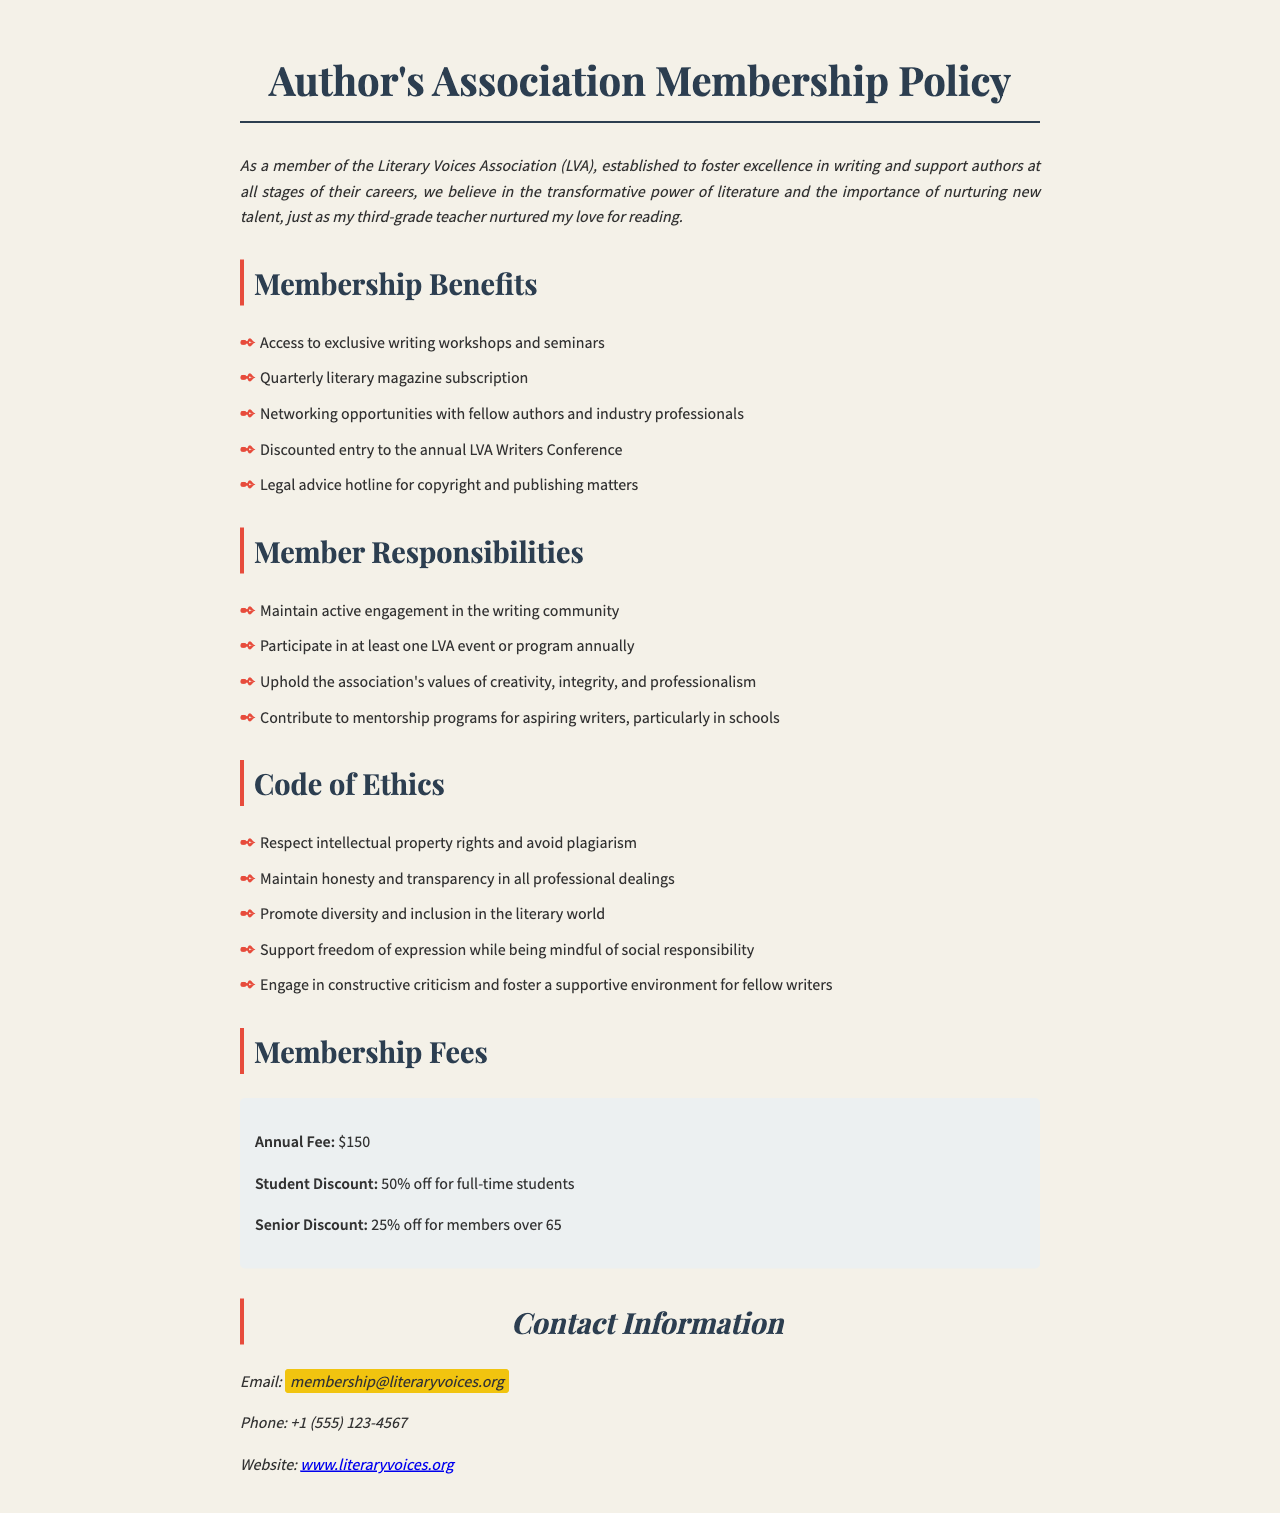What are the membership fees? The membership fees listed in the document are specified under "Membership Fees".
Answer: $150 What is the student discount rate? The student discount rate is mentioned in the "Membership Fees" section.
Answer: 50% off What is one benefit of membership? One of the benefits of membership can be found in the "Membership Benefits" section.
Answer: Access to exclusive writing workshops and seminars How many events must a member participate in annually? This requirement is found in the "Member Responsibilities" section of the document.
Answer: At least one Name one aspect of the code of ethics. This can be found in the "Code of Ethics" section, requiring members to adhere to specific ethical guidelines.
Answer: Respect intellectual property rights and avoid plagiarism What is the contact email for membership inquiries? The contact email is located in the "Contact Information" section.
Answer: membership@literaryvoices.org What percentage discount do senior members receive? This information is in the "Membership Fees" section regarding senior members' fees.
Answer: 25% off What is the purpose of the Literary Voices Association? The purpose is described in the introductory paragraph of the document.
Answer: Foster excellence in writing and support authors at all stages of their careers 